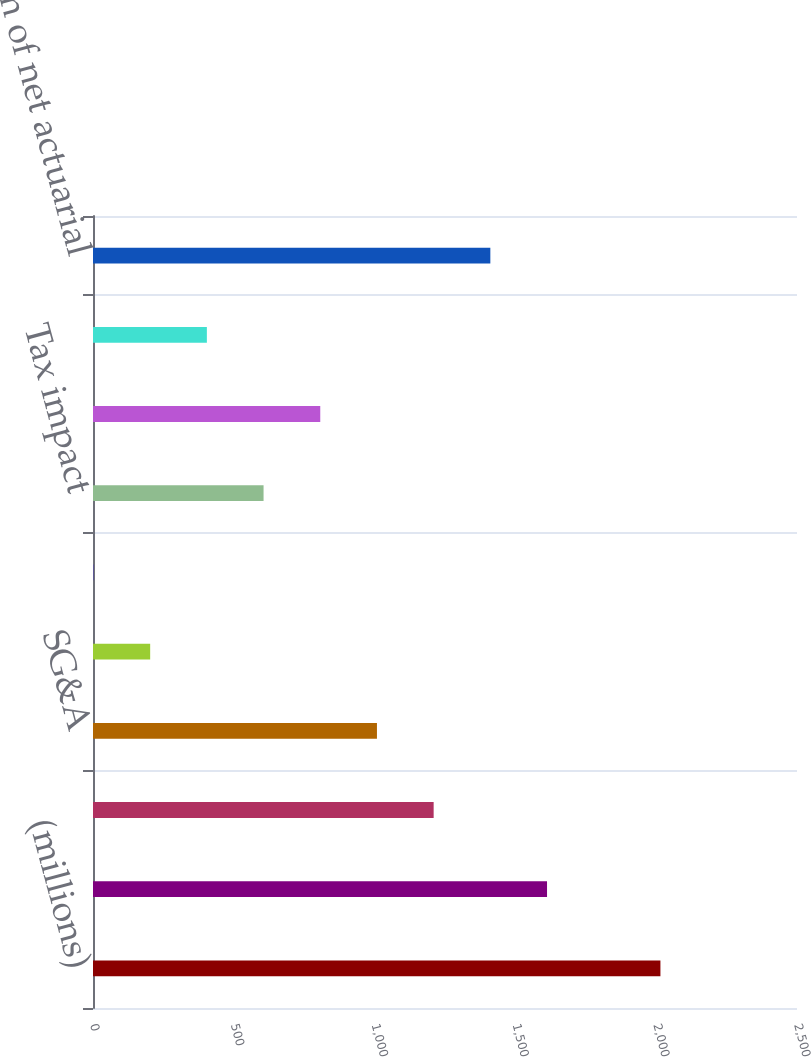<chart> <loc_0><loc_0><loc_500><loc_500><bar_chart><fcel>(millions)<fcel>Amount recognized in AOCI<fcel>Cost of sales<fcel>SG&A<fcel>Interest (income) expense net<fcel>Other activity<fcel>Tax impact<fcel>Net of tax<fcel>Current period net actuarial<fcel>Amortization of net actuarial<nl><fcel>2015<fcel>1612.34<fcel>1209.68<fcel>1008.35<fcel>203.03<fcel>1.7<fcel>605.69<fcel>807.02<fcel>404.36<fcel>1411.01<nl></chart> 